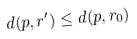Convert formula to latex. <formula><loc_0><loc_0><loc_500><loc_500>d ( p , r ^ { \prime } ) \leq d ( p , r _ { 0 } )</formula> 